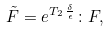Convert formula to latex. <formula><loc_0><loc_0><loc_500><loc_500>\tilde { F } = e ^ { T _ { 2 } \, \frac { \delta } { \epsilon } } \colon F ,</formula> 